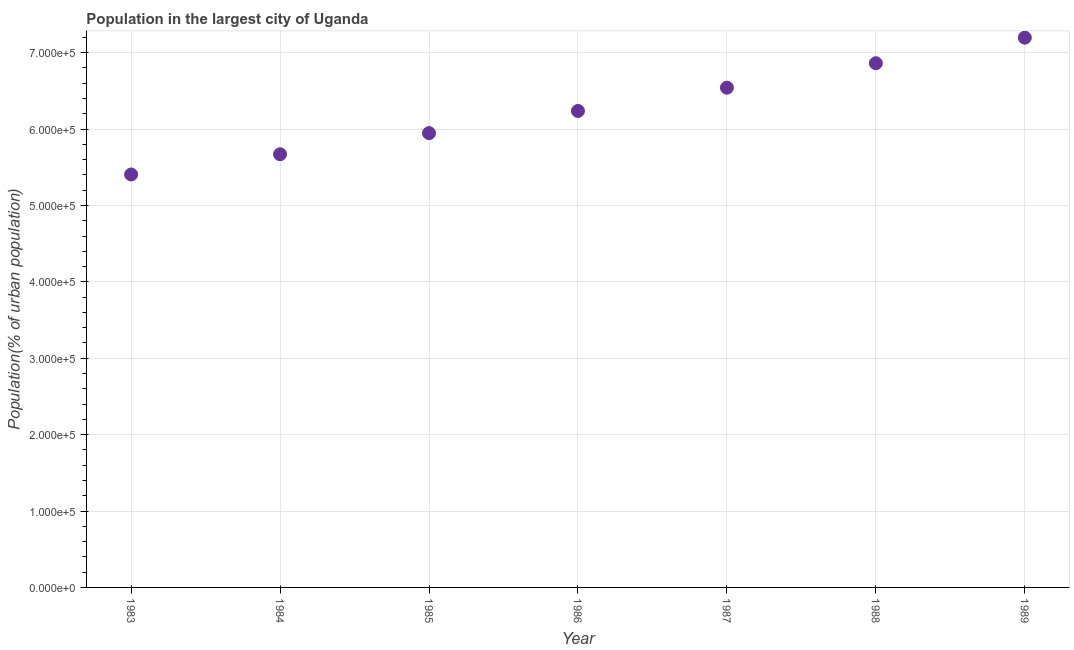What is the population in largest city in 1986?
Your answer should be very brief. 6.24e+05. Across all years, what is the maximum population in largest city?
Provide a short and direct response. 7.20e+05. Across all years, what is the minimum population in largest city?
Offer a very short reply. 5.41e+05. In which year was the population in largest city maximum?
Keep it short and to the point. 1989. What is the sum of the population in largest city?
Give a very brief answer. 4.39e+06. What is the difference between the population in largest city in 1985 and 1988?
Keep it short and to the point. -9.15e+04. What is the average population in largest city per year?
Your response must be concise. 6.27e+05. What is the median population in largest city?
Ensure brevity in your answer.  6.24e+05. Do a majority of the years between 1985 and 1988 (inclusive) have population in largest city greater than 600000 %?
Provide a succinct answer. Yes. What is the ratio of the population in largest city in 1988 to that in 1989?
Your answer should be very brief. 0.95. What is the difference between the highest and the second highest population in largest city?
Your response must be concise. 3.35e+04. Is the sum of the population in largest city in 1984 and 1988 greater than the maximum population in largest city across all years?
Offer a terse response. Yes. What is the difference between the highest and the lowest population in largest city?
Offer a very short reply. 1.79e+05. Does the population in largest city monotonically increase over the years?
Your response must be concise. Yes. How many dotlines are there?
Keep it short and to the point. 1. Does the graph contain any zero values?
Provide a short and direct response. No. Does the graph contain grids?
Offer a terse response. Yes. What is the title of the graph?
Provide a succinct answer. Population in the largest city of Uganda. What is the label or title of the X-axis?
Offer a very short reply. Year. What is the label or title of the Y-axis?
Ensure brevity in your answer.  Population(% of urban population). What is the Population(% of urban population) in 1983?
Provide a succinct answer. 5.41e+05. What is the Population(% of urban population) in 1984?
Provide a short and direct response. 5.67e+05. What is the Population(% of urban population) in 1985?
Make the answer very short. 5.95e+05. What is the Population(% of urban population) in 1986?
Provide a short and direct response. 6.24e+05. What is the Population(% of urban population) in 1987?
Make the answer very short. 6.54e+05. What is the Population(% of urban population) in 1988?
Give a very brief answer. 6.86e+05. What is the Population(% of urban population) in 1989?
Offer a terse response. 7.20e+05. What is the difference between the Population(% of urban population) in 1983 and 1984?
Your response must be concise. -2.64e+04. What is the difference between the Population(% of urban population) in 1983 and 1985?
Make the answer very short. -5.41e+04. What is the difference between the Population(% of urban population) in 1983 and 1986?
Make the answer very short. -8.31e+04. What is the difference between the Population(% of urban population) in 1983 and 1987?
Give a very brief answer. -1.14e+05. What is the difference between the Population(% of urban population) in 1983 and 1988?
Provide a succinct answer. -1.46e+05. What is the difference between the Population(% of urban population) in 1983 and 1989?
Give a very brief answer. -1.79e+05. What is the difference between the Population(% of urban population) in 1984 and 1985?
Your answer should be compact. -2.77e+04. What is the difference between the Population(% of urban population) in 1984 and 1986?
Provide a succinct answer. -5.67e+04. What is the difference between the Population(% of urban population) in 1984 and 1987?
Keep it short and to the point. -8.72e+04. What is the difference between the Population(% of urban population) in 1984 and 1988?
Provide a succinct answer. -1.19e+05. What is the difference between the Population(% of urban population) in 1984 and 1989?
Provide a short and direct response. -1.53e+05. What is the difference between the Population(% of urban population) in 1985 and 1986?
Give a very brief answer. -2.90e+04. What is the difference between the Population(% of urban population) in 1985 and 1987?
Your answer should be very brief. -5.95e+04. What is the difference between the Population(% of urban population) in 1985 and 1988?
Keep it short and to the point. -9.15e+04. What is the difference between the Population(% of urban population) in 1985 and 1989?
Keep it short and to the point. -1.25e+05. What is the difference between the Population(% of urban population) in 1986 and 1987?
Your response must be concise. -3.05e+04. What is the difference between the Population(% of urban population) in 1986 and 1988?
Offer a terse response. -6.25e+04. What is the difference between the Population(% of urban population) in 1986 and 1989?
Your response must be concise. -9.59e+04. What is the difference between the Population(% of urban population) in 1987 and 1988?
Offer a terse response. -3.20e+04. What is the difference between the Population(% of urban population) in 1987 and 1989?
Provide a short and direct response. -6.55e+04. What is the difference between the Population(% of urban population) in 1988 and 1989?
Provide a short and direct response. -3.35e+04. What is the ratio of the Population(% of urban population) in 1983 to that in 1984?
Your response must be concise. 0.95. What is the ratio of the Population(% of urban population) in 1983 to that in 1985?
Provide a short and direct response. 0.91. What is the ratio of the Population(% of urban population) in 1983 to that in 1986?
Provide a short and direct response. 0.87. What is the ratio of the Population(% of urban population) in 1983 to that in 1987?
Make the answer very short. 0.83. What is the ratio of the Population(% of urban population) in 1983 to that in 1988?
Provide a short and direct response. 0.79. What is the ratio of the Population(% of urban population) in 1983 to that in 1989?
Your answer should be compact. 0.75. What is the ratio of the Population(% of urban population) in 1984 to that in 1985?
Your answer should be very brief. 0.95. What is the ratio of the Population(% of urban population) in 1984 to that in 1986?
Keep it short and to the point. 0.91. What is the ratio of the Population(% of urban population) in 1984 to that in 1987?
Keep it short and to the point. 0.87. What is the ratio of the Population(% of urban population) in 1984 to that in 1988?
Provide a short and direct response. 0.83. What is the ratio of the Population(% of urban population) in 1984 to that in 1989?
Offer a very short reply. 0.79. What is the ratio of the Population(% of urban population) in 1985 to that in 1986?
Keep it short and to the point. 0.95. What is the ratio of the Population(% of urban population) in 1985 to that in 1987?
Offer a terse response. 0.91. What is the ratio of the Population(% of urban population) in 1985 to that in 1988?
Offer a terse response. 0.87. What is the ratio of the Population(% of urban population) in 1985 to that in 1989?
Your response must be concise. 0.83. What is the ratio of the Population(% of urban population) in 1986 to that in 1987?
Your answer should be compact. 0.95. What is the ratio of the Population(% of urban population) in 1986 to that in 1988?
Your response must be concise. 0.91. What is the ratio of the Population(% of urban population) in 1986 to that in 1989?
Offer a very short reply. 0.87. What is the ratio of the Population(% of urban population) in 1987 to that in 1988?
Your response must be concise. 0.95. What is the ratio of the Population(% of urban population) in 1987 to that in 1989?
Ensure brevity in your answer.  0.91. What is the ratio of the Population(% of urban population) in 1988 to that in 1989?
Make the answer very short. 0.95. 